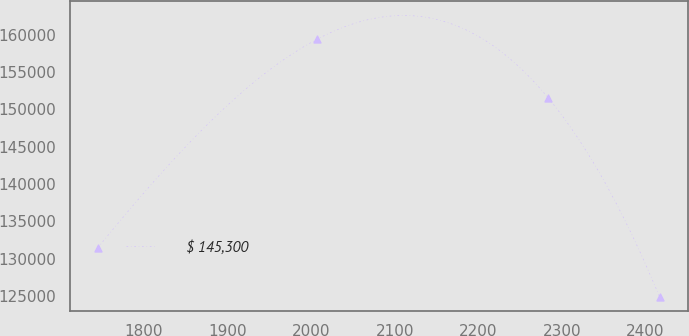Convert chart. <chart><loc_0><loc_0><loc_500><loc_500><line_chart><ecel><fcel>$ 145,300<nl><fcel>1744.84<fcel>131462<nl><fcel>2007.36<fcel>159428<nl><fcel>2283.64<fcel>151537<nl><fcel>2416.71<fcel>124883<nl></chart> 